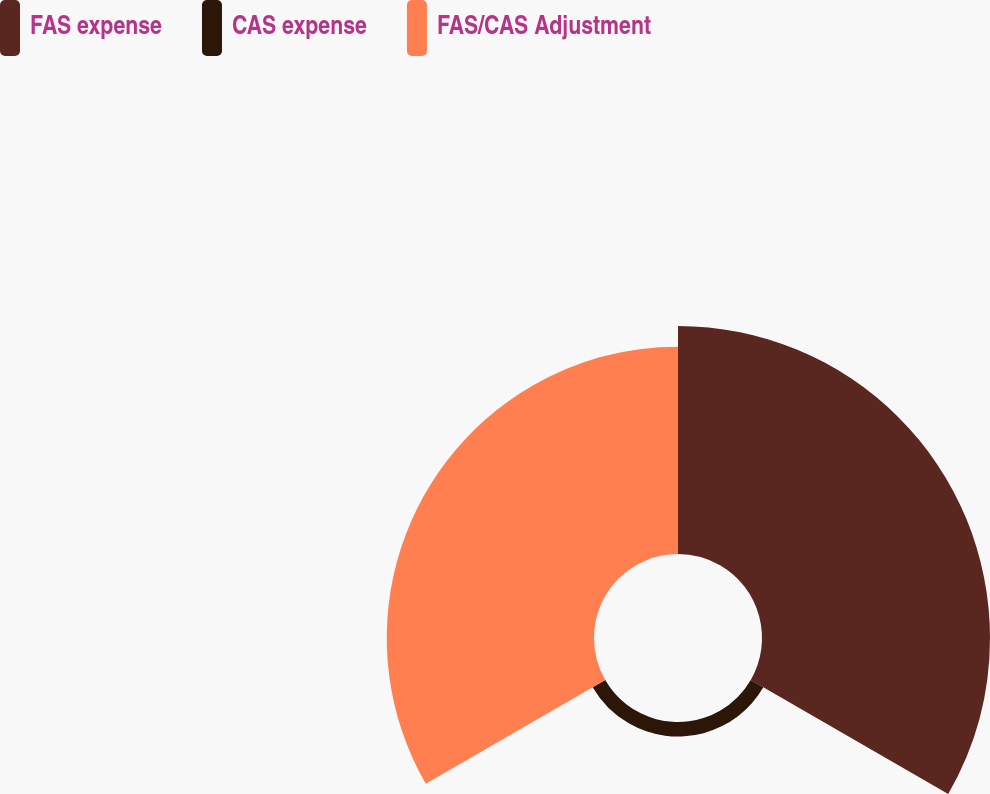Convert chart. <chart><loc_0><loc_0><loc_500><loc_500><pie_chart><fcel>FAS expense<fcel>CAS expense<fcel>FAS/CAS Adjustment<nl><fcel>50.69%<fcel>3.23%<fcel>46.08%<nl></chart> 